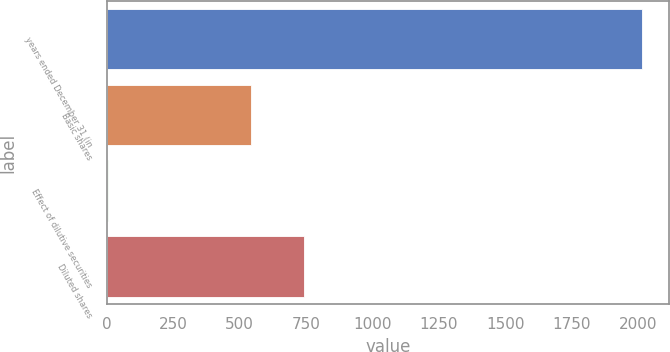Convert chart to OTSL. <chart><loc_0><loc_0><loc_500><loc_500><bar_chart><fcel>years ended December 31 (in<fcel>Basic shares<fcel>Effect of dilutive securities<fcel>Diluted shares<nl><fcel>2014<fcel>542<fcel>5<fcel>742.9<nl></chart> 